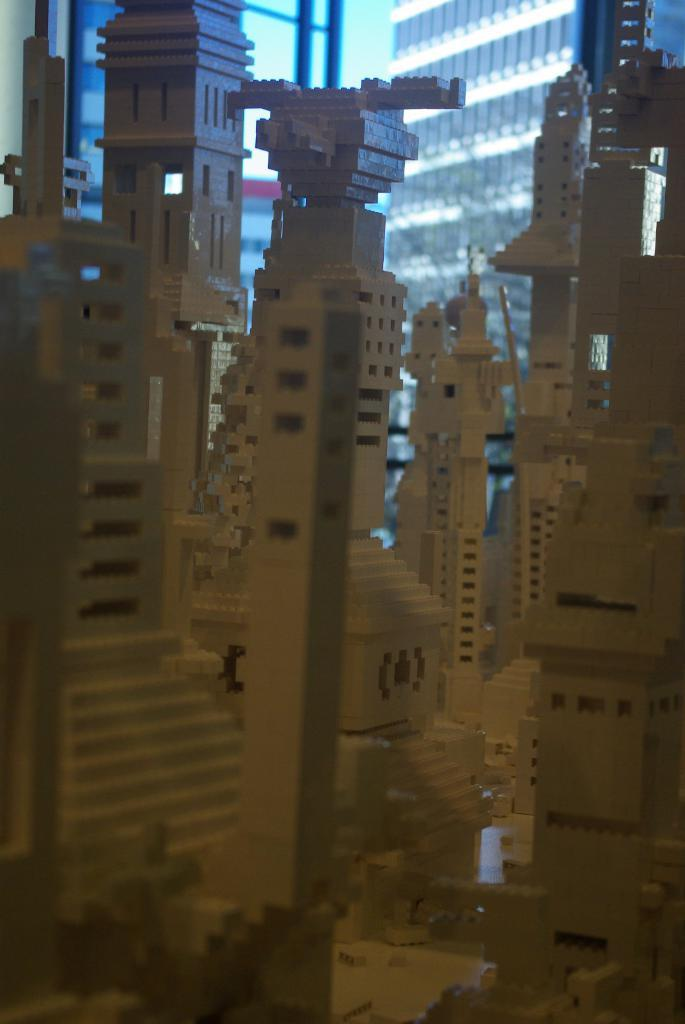What type of structures are depicted in the image? There are wooden structures of buildings in the image. What is the rate of payment for the clocks in the image? There are no clocks present in the image, so it is not possible to determine the rate of payment for them. 